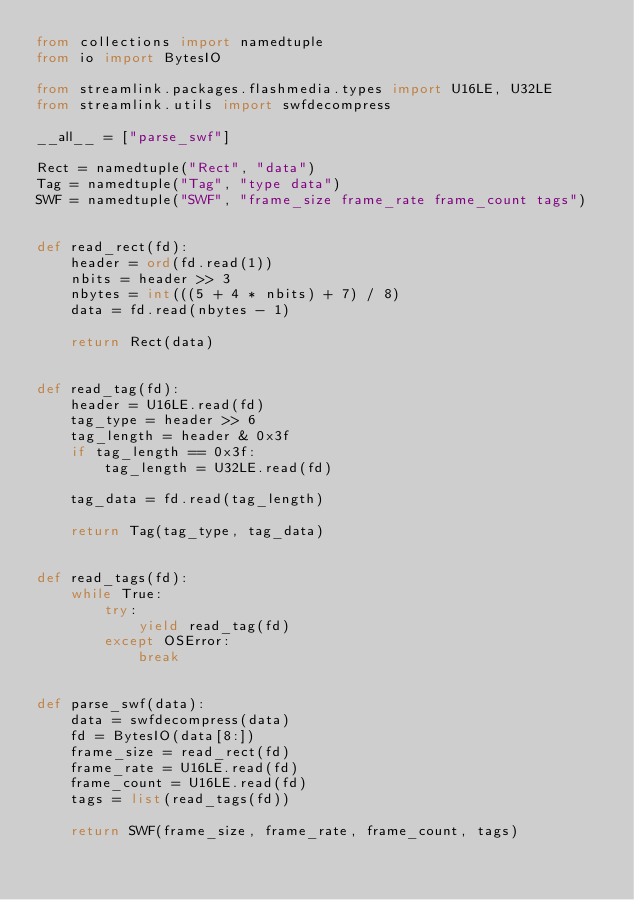<code> <loc_0><loc_0><loc_500><loc_500><_Python_>from collections import namedtuple
from io import BytesIO

from streamlink.packages.flashmedia.types import U16LE, U32LE
from streamlink.utils import swfdecompress

__all__ = ["parse_swf"]

Rect = namedtuple("Rect", "data")
Tag = namedtuple("Tag", "type data")
SWF = namedtuple("SWF", "frame_size frame_rate frame_count tags")


def read_rect(fd):
    header = ord(fd.read(1))
    nbits = header >> 3
    nbytes = int(((5 + 4 * nbits) + 7) / 8)
    data = fd.read(nbytes - 1)

    return Rect(data)


def read_tag(fd):
    header = U16LE.read(fd)
    tag_type = header >> 6
    tag_length = header & 0x3f
    if tag_length == 0x3f:
        tag_length = U32LE.read(fd)

    tag_data = fd.read(tag_length)

    return Tag(tag_type, tag_data)


def read_tags(fd):
    while True:
        try:
            yield read_tag(fd)
        except OSError:
            break


def parse_swf(data):
    data = swfdecompress(data)
    fd = BytesIO(data[8:])
    frame_size = read_rect(fd)
    frame_rate = U16LE.read(fd)
    frame_count = U16LE.read(fd)
    tags = list(read_tags(fd))

    return SWF(frame_size, frame_rate, frame_count, tags)
</code> 